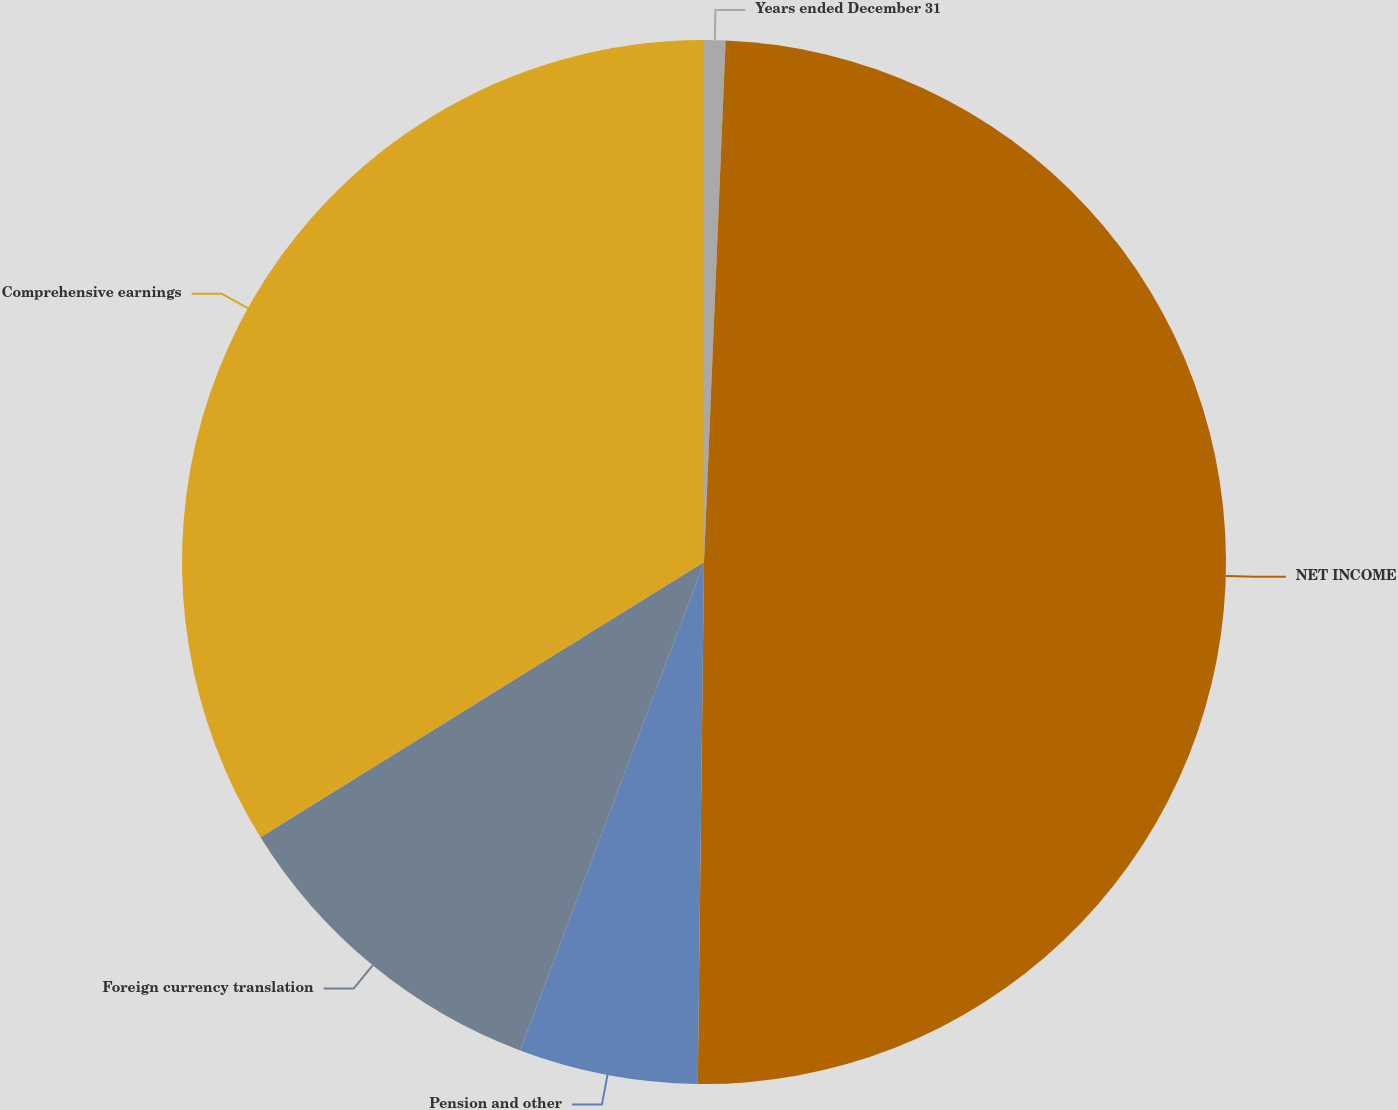Convert chart to OTSL. <chart><loc_0><loc_0><loc_500><loc_500><pie_chart><fcel>Years ended December 31<fcel>NET INCOME<fcel>Pension and other<fcel>Foreign currency translation<fcel>Comprehensive earnings<nl><fcel>0.66%<fcel>49.53%<fcel>5.54%<fcel>10.43%<fcel>33.84%<nl></chart> 